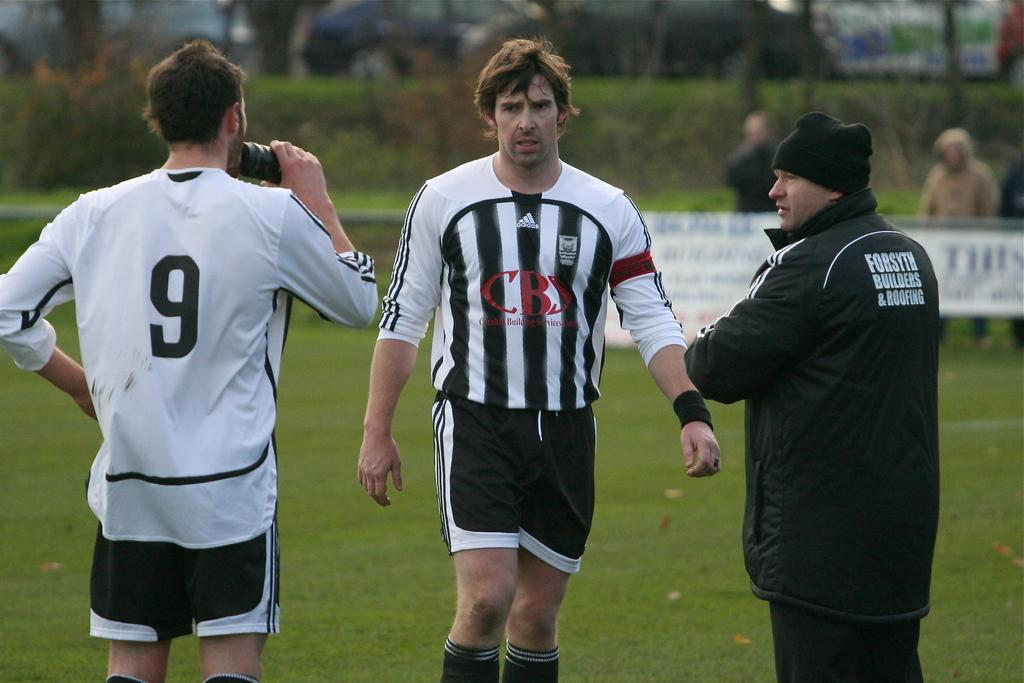How many people are in the image? There are three persons standing in the image. What is the person in front wearing? The person in front is wearing a black and white dress. Can you describe the other two persons in the image? There are two other persons standing in the background of the image. What can be seen in the background of the image? Trees and green grass are visible in the background of the image. What type of neck can be seen on the trees in the image? There are no necks present on the trees in the image, as trees do not have necks. What is the starting point for the person in the black and white dress? The image does not provide information about a starting point for the person in the black and white dress, as it only shows a static scene. 